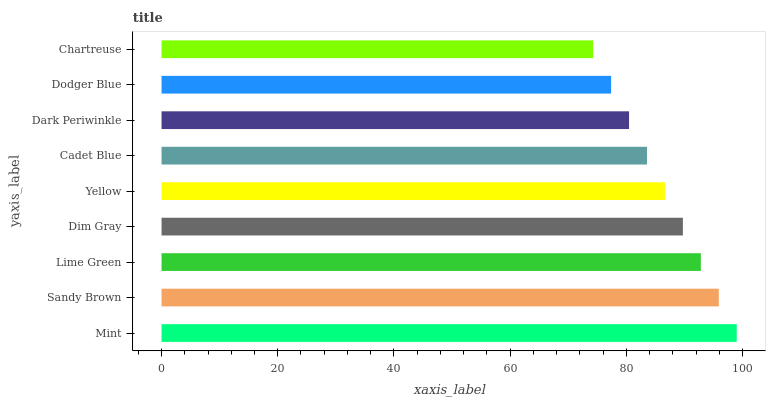Is Chartreuse the minimum?
Answer yes or no. Yes. Is Mint the maximum?
Answer yes or no. Yes. Is Sandy Brown the minimum?
Answer yes or no. No. Is Sandy Brown the maximum?
Answer yes or no. No. Is Mint greater than Sandy Brown?
Answer yes or no. Yes. Is Sandy Brown less than Mint?
Answer yes or no. Yes. Is Sandy Brown greater than Mint?
Answer yes or no. No. Is Mint less than Sandy Brown?
Answer yes or no. No. Is Yellow the high median?
Answer yes or no. Yes. Is Yellow the low median?
Answer yes or no. Yes. Is Lime Green the high median?
Answer yes or no. No. Is Chartreuse the low median?
Answer yes or no. No. 